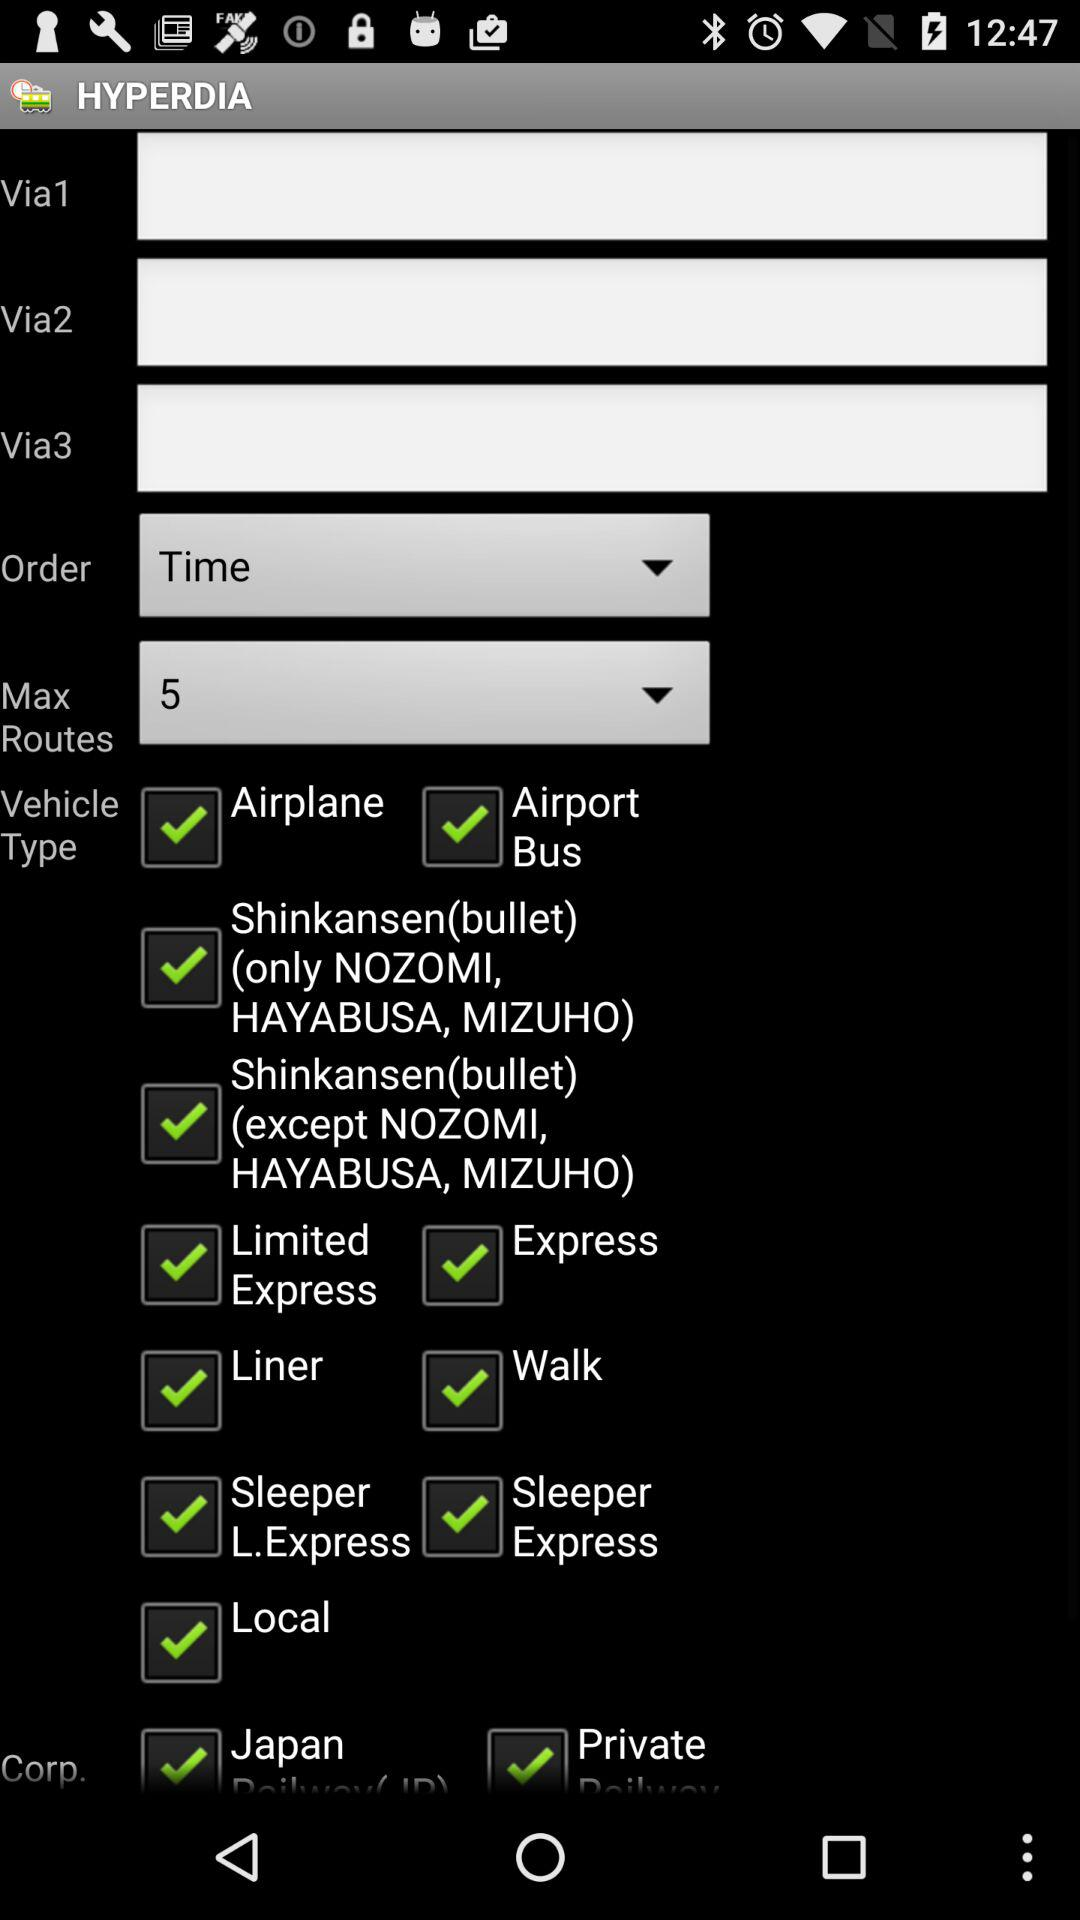Which are the different vehicle types? The different vehicle types are "Airplane", "Airport Bus", "Shinkansen(bullet) (only NOZOMI, HAYABUSA, MIZUHO)", "Shinkansen(bullet) (except NOZOMI, HAYABUSA, MIZUHO)", "Limited Express", "Express", "Liner", "Walk", "Sleeper L.Express", "Sleeper Express" and "Local". 